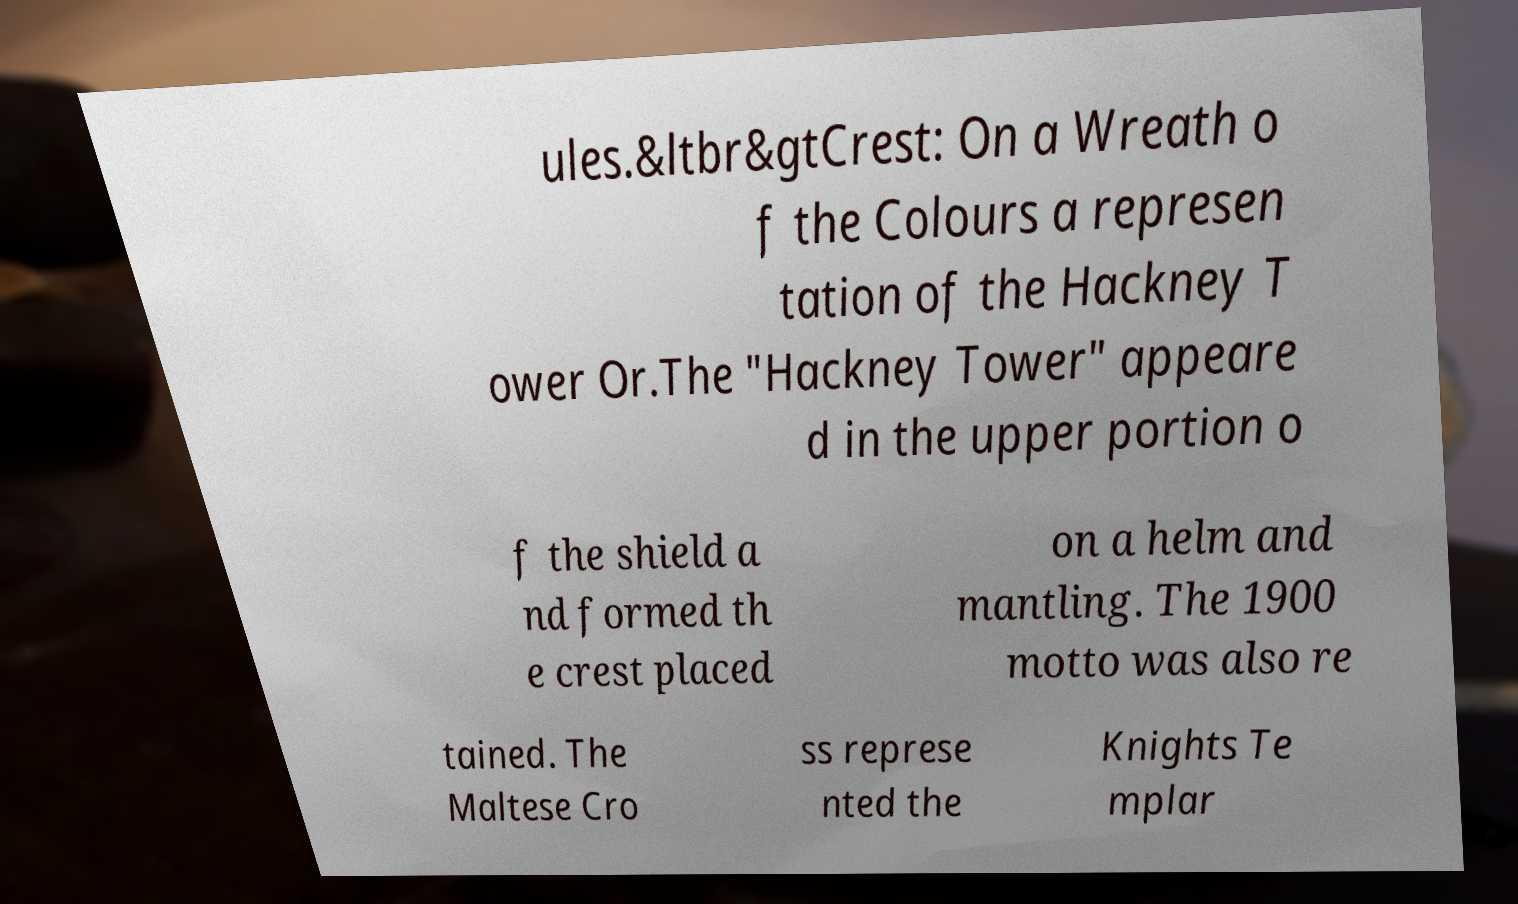Can you read and provide the text displayed in the image?This photo seems to have some interesting text. Can you extract and type it out for me? ules.&ltbr&gtCrest: On a Wreath o f the Colours a represen tation of the Hackney T ower Or.The "Hackney Tower" appeare d in the upper portion o f the shield a nd formed th e crest placed on a helm and mantling. The 1900 motto was also re tained. The Maltese Cro ss represe nted the Knights Te mplar 